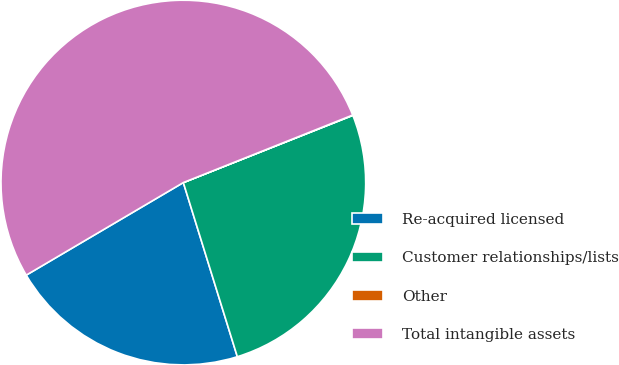<chart> <loc_0><loc_0><loc_500><loc_500><pie_chart><fcel>Re-acquired licensed<fcel>Customer relationships/lists<fcel>Other<fcel>Total intangible assets<nl><fcel>21.31%<fcel>26.22%<fcel>0.03%<fcel>52.44%<nl></chart> 